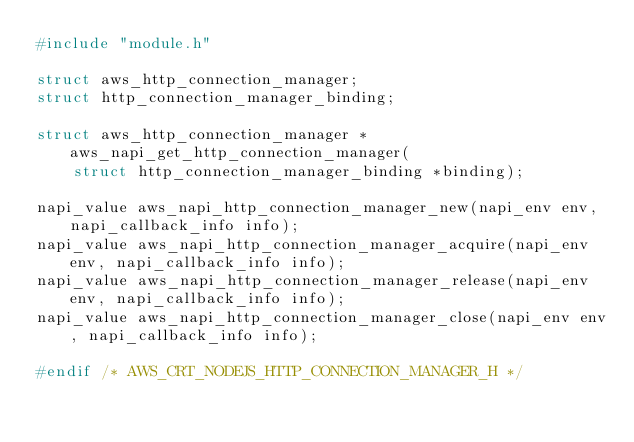Convert code to text. <code><loc_0><loc_0><loc_500><loc_500><_C_>#include "module.h"

struct aws_http_connection_manager;
struct http_connection_manager_binding;

struct aws_http_connection_manager *aws_napi_get_http_connection_manager(
    struct http_connection_manager_binding *binding);

napi_value aws_napi_http_connection_manager_new(napi_env env, napi_callback_info info);
napi_value aws_napi_http_connection_manager_acquire(napi_env env, napi_callback_info info);
napi_value aws_napi_http_connection_manager_release(napi_env env, napi_callback_info info);
napi_value aws_napi_http_connection_manager_close(napi_env env, napi_callback_info info);

#endif /* AWS_CRT_NODEJS_HTTP_CONNECTION_MANAGER_H */
</code> 